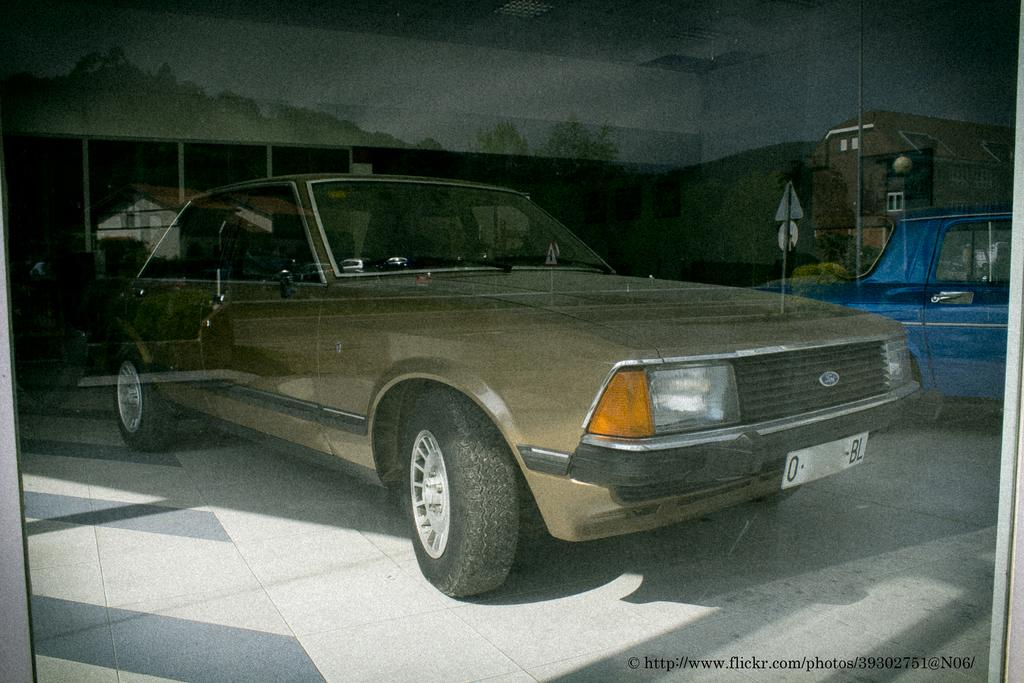What objects are on the floor in the image? There are vehicles on the floor in the image. What can be seen in the background of the image? There are poles in the background of the image. What is written or displayed at the bottom of the image? There is some text at the bottom of the image. What type of structure is visible in the image? There is a roof and a wall in the image. Can you tell me how many babies are crawling in the quicksand in the image? There is no quicksand or baby present in the image. What direction are the vehicles pointing in the image? The provided facts do not mention the direction the vehicles are pointing, so it cannot be determined from the image. 